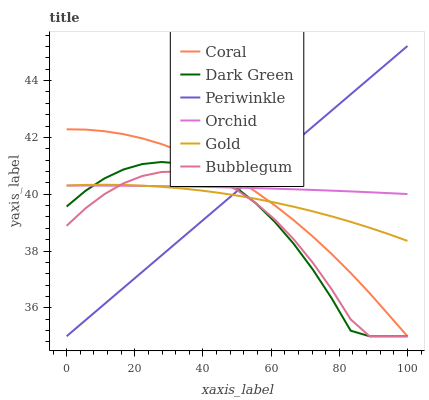Does Bubblegum have the minimum area under the curve?
Answer yes or no. Yes. Does Orchid have the maximum area under the curve?
Answer yes or no. Yes. Does Coral have the minimum area under the curve?
Answer yes or no. No. Does Coral have the maximum area under the curve?
Answer yes or no. No. Is Periwinkle the smoothest?
Answer yes or no. Yes. Is Dark Green the roughest?
Answer yes or no. Yes. Is Coral the smoothest?
Answer yes or no. No. Is Coral the roughest?
Answer yes or no. No. Does Coral have the lowest value?
Answer yes or no. Yes. Does Orchid have the lowest value?
Answer yes or no. No. Does Periwinkle have the highest value?
Answer yes or no. Yes. Does Coral have the highest value?
Answer yes or no. No. Does Orchid intersect Coral?
Answer yes or no. Yes. Is Orchid less than Coral?
Answer yes or no. No. Is Orchid greater than Coral?
Answer yes or no. No. 